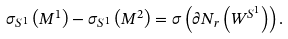Convert formula to latex. <formula><loc_0><loc_0><loc_500><loc_500>\sigma _ { S ^ { 1 } } \left ( M ^ { 1 } \right ) - \sigma _ { S ^ { 1 } } \left ( M ^ { 2 } \right ) = \sigma \left ( \partial N _ { r } \left ( W ^ { S ^ { 1 } } \right ) \right ) .</formula> 